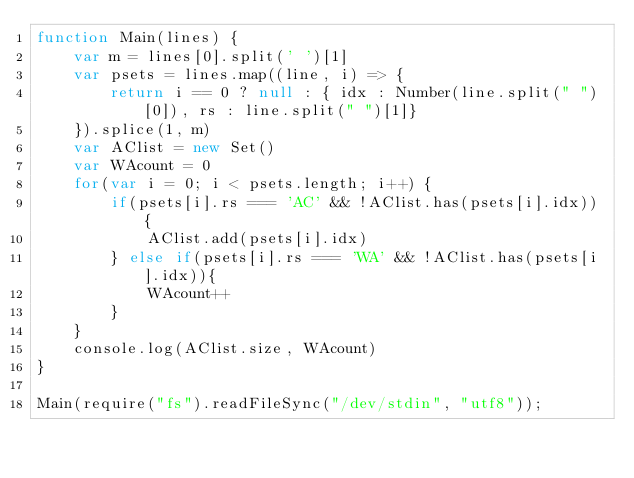<code> <loc_0><loc_0><loc_500><loc_500><_JavaScript_>function Main(lines) {
	var m = lines[0].split(' ')[1]
	var psets = lines.map((line, i) => {
		return i == 0 ? null : { idx : Number(line.split(" ")[0]), rs : line.split(" ")[1]}
	}).splice(1, m)
	var AClist = new Set()
	var WAcount = 0
	for(var i = 0; i < psets.length; i++) {
		if(psets[i].rs === 'AC' && !AClist.has(psets[i].idx)) {
			AClist.add(psets[i].idx)
		} else if(psets[i].rs === 'WA' && !AClist.has(psets[i].idx)){
			WAcount++
		}
	}
	console.log(AClist.size, WAcount)
}

Main(require("fs").readFileSync("/dev/stdin", "utf8"));</code> 